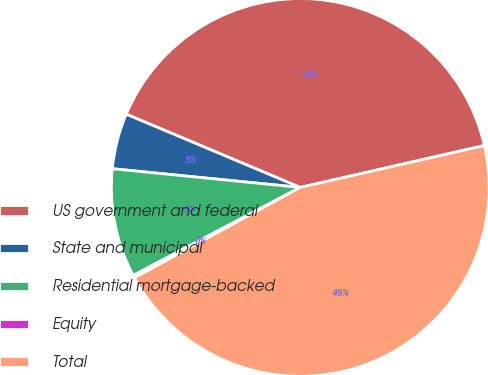Convert chart to OTSL. <chart><loc_0><loc_0><loc_500><loc_500><pie_chart><fcel>US government and federal<fcel>State and municipal<fcel>Residential mortgage-backed<fcel>Equity<fcel>Total<nl><fcel>40.1%<fcel>4.76%<fcel>9.3%<fcel>0.22%<fcel>45.63%<nl></chart> 